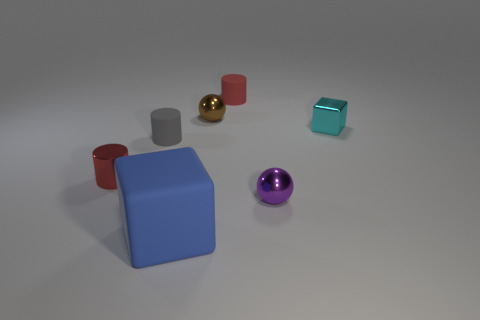Subtract all blue spheres. How many red cylinders are left? 2 Subtract all tiny red cylinders. How many cylinders are left? 1 Subtract 1 cylinders. How many cylinders are left? 2 Add 3 rubber cylinders. How many objects exist? 10 Subtract all cylinders. How many objects are left? 4 Subtract all blue cylinders. Subtract all purple balls. How many cylinders are left? 3 Subtract 0 yellow spheres. How many objects are left? 7 Subtract all tiny red rubber cylinders. Subtract all shiny spheres. How many objects are left? 4 Add 5 small cyan metallic things. How many small cyan metallic things are left? 6 Add 7 small matte things. How many small matte things exist? 9 